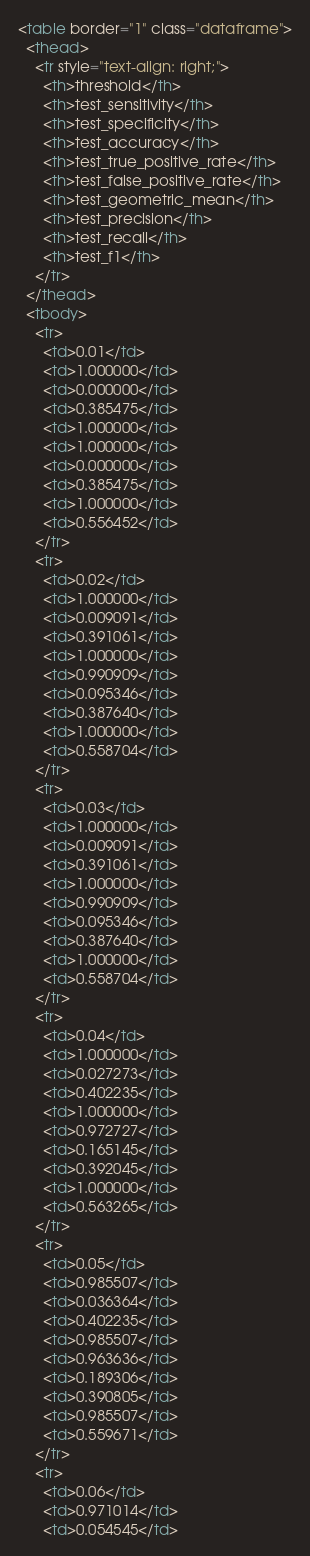<code> <loc_0><loc_0><loc_500><loc_500><_HTML_><table border="1" class="dataframe">
  <thead>
    <tr style="text-align: right;">
      <th>threshold</th>
      <th>test_sensitivity</th>
      <th>test_specificity</th>
      <th>test_accuracy</th>
      <th>test_true_positive_rate</th>
      <th>test_false_positive_rate</th>
      <th>test_geometric_mean</th>
      <th>test_precision</th>
      <th>test_recall</th>
      <th>test_f1</th>
    </tr>
  </thead>
  <tbody>
    <tr>
      <td>0.01</td>
      <td>1.000000</td>
      <td>0.000000</td>
      <td>0.385475</td>
      <td>1.000000</td>
      <td>1.000000</td>
      <td>0.000000</td>
      <td>0.385475</td>
      <td>1.000000</td>
      <td>0.556452</td>
    </tr>
    <tr>
      <td>0.02</td>
      <td>1.000000</td>
      <td>0.009091</td>
      <td>0.391061</td>
      <td>1.000000</td>
      <td>0.990909</td>
      <td>0.095346</td>
      <td>0.387640</td>
      <td>1.000000</td>
      <td>0.558704</td>
    </tr>
    <tr>
      <td>0.03</td>
      <td>1.000000</td>
      <td>0.009091</td>
      <td>0.391061</td>
      <td>1.000000</td>
      <td>0.990909</td>
      <td>0.095346</td>
      <td>0.387640</td>
      <td>1.000000</td>
      <td>0.558704</td>
    </tr>
    <tr>
      <td>0.04</td>
      <td>1.000000</td>
      <td>0.027273</td>
      <td>0.402235</td>
      <td>1.000000</td>
      <td>0.972727</td>
      <td>0.165145</td>
      <td>0.392045</td>
      <td>1.000000</td>
      <td>0.563265</td>
    </tr>
    <tr>
      <td>0.05</td>
      <td>0.985507</td>
      <td>0.036364</td>
      <td>0.402235</td>
      <td>0.985507</td>
      <td>0.963636</td>
      <td>0.189306</td>
      <td>0.390805</td>
      <td>0.985507</td>
      <td>0.559671</td>
    </tr>
    <tr>
      <td>0.06</td>
      <td>0.971014</td>
      <td>0.054545</td></code> 